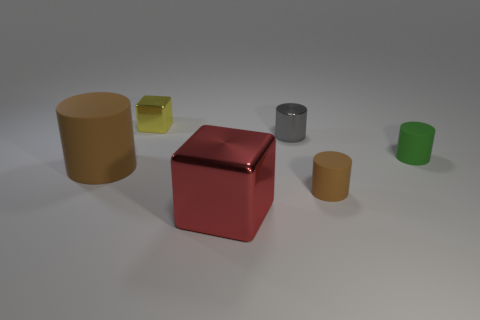How many tiny gray shiny objects have the same shape as the big red metallic object?
Provide a short and direct response. 0. There is a thing that is both to the right of the big shiny cube and behind the green cylinder; what is its material?
Make the answer very short. Metal. Do the tiny green thing and the gray object have the same material?
Provide a succinct answer. No. How many green matte cylinders are there?
Your answer should be compact. 1. What is the color of the small object on the left side of the big red metallic block that is on the right side of the shiny thing behind the gray metallic thing?
Provide a succinct answer. Yellow. Does the large matte cylinder have the same color as the large metal object?
Give a very brief answer. No. How many brown matte objects are both behind the tiny brown matte thing and to the right of the small gray cylinder?
Your response must be concise. 0. How many matte things are either cubes or gray things?
Your answer should be very brief. 0. The small cylinder on the right side of the tiny cylinder in front of the big matte cylinder is made of what material?
Provide a short and direct response. Rubber. What is the shape of the small matte thing that is the same color as the large cylinder?
Offer a terse response. Cylinder. 